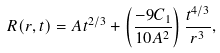Convert formula to latex. <formula><loc_0><loc_0><loc_500><loc_500>R ( r , t ) = A t ^ { 2 / 3 } + \left ( \frac { - 9 C _ { 1 } } { 1 0 A ^ { 2 } } \right ) \frac { t ^ { 4 / 3 } } { r ^ { 3 } } ,</formula> 